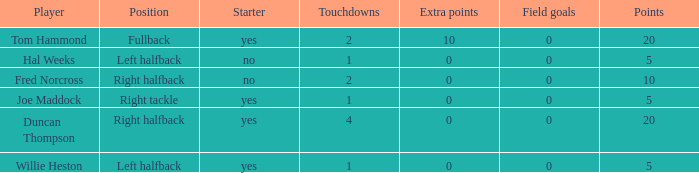What is the lowest number of field goals when the points were less than 5? None. 